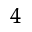Convert formula to latex. <formula><loc_0><loc_0><loc_500><loc_500>^ { 4 }</formula> 